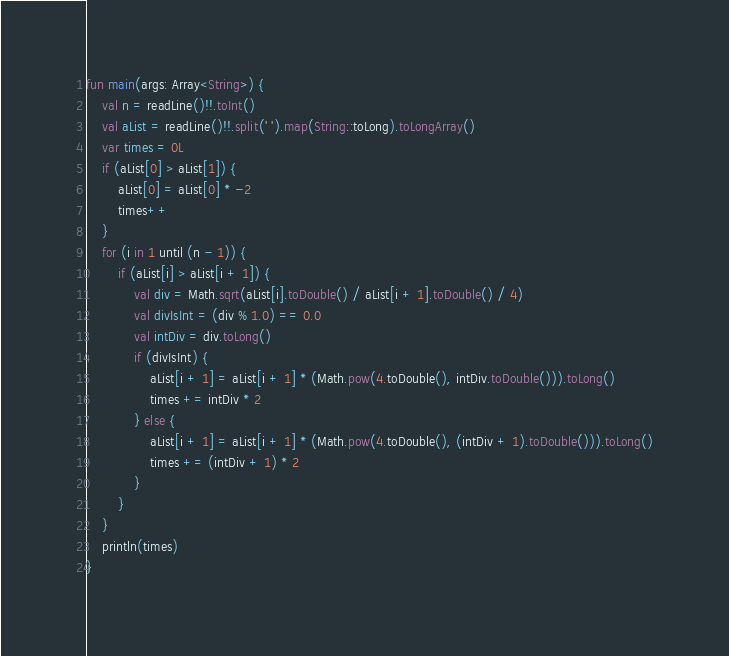<code> <loc_0><loc_0><loc_500><loc_500><_Kotlin_>fun main(args: Array<String>) {
    val n = readLine()!!.toInt()
    val aList = readLine()!!.split(' ').map(String::toLong).toLongArray()
    var times = 0L
    if (aList[0] > aList[1]) {
        aList[0] = aList[0] * -2
        times++
    }
    for (i in 1 until (n - 1)) {
        if (aList[i] > aList[i + 1]) {
            val div = Math.sqrt(aList[i].toDouble() / aList[i + 1].toDouble() / 4)
            val divIsInt = (div % 1.0) == 0.0
            val intDiv = div.toLong()
            if (divIsInt) {
                aList[i + 1] = aList[i + 1] * (Math.pow(4.toDouble(), intDiv.toDouble())).toLong()
                times += intDiv * 2
            } else {
                aList[i + 1] = aList[i + 1] * (Math.pow(4.toDouble(), (intDiv + 1).toDouble())).toLong()
                times += (intDiv + 1) * 2
            }
        }
    }
    println(times)
}
</code> 